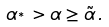<formula> <loc_0><loc_0><loc_500><loc_500>\alpha _ { ^ { * } } > \alpha \geq \tilde { \alpha } \, .</formula> 